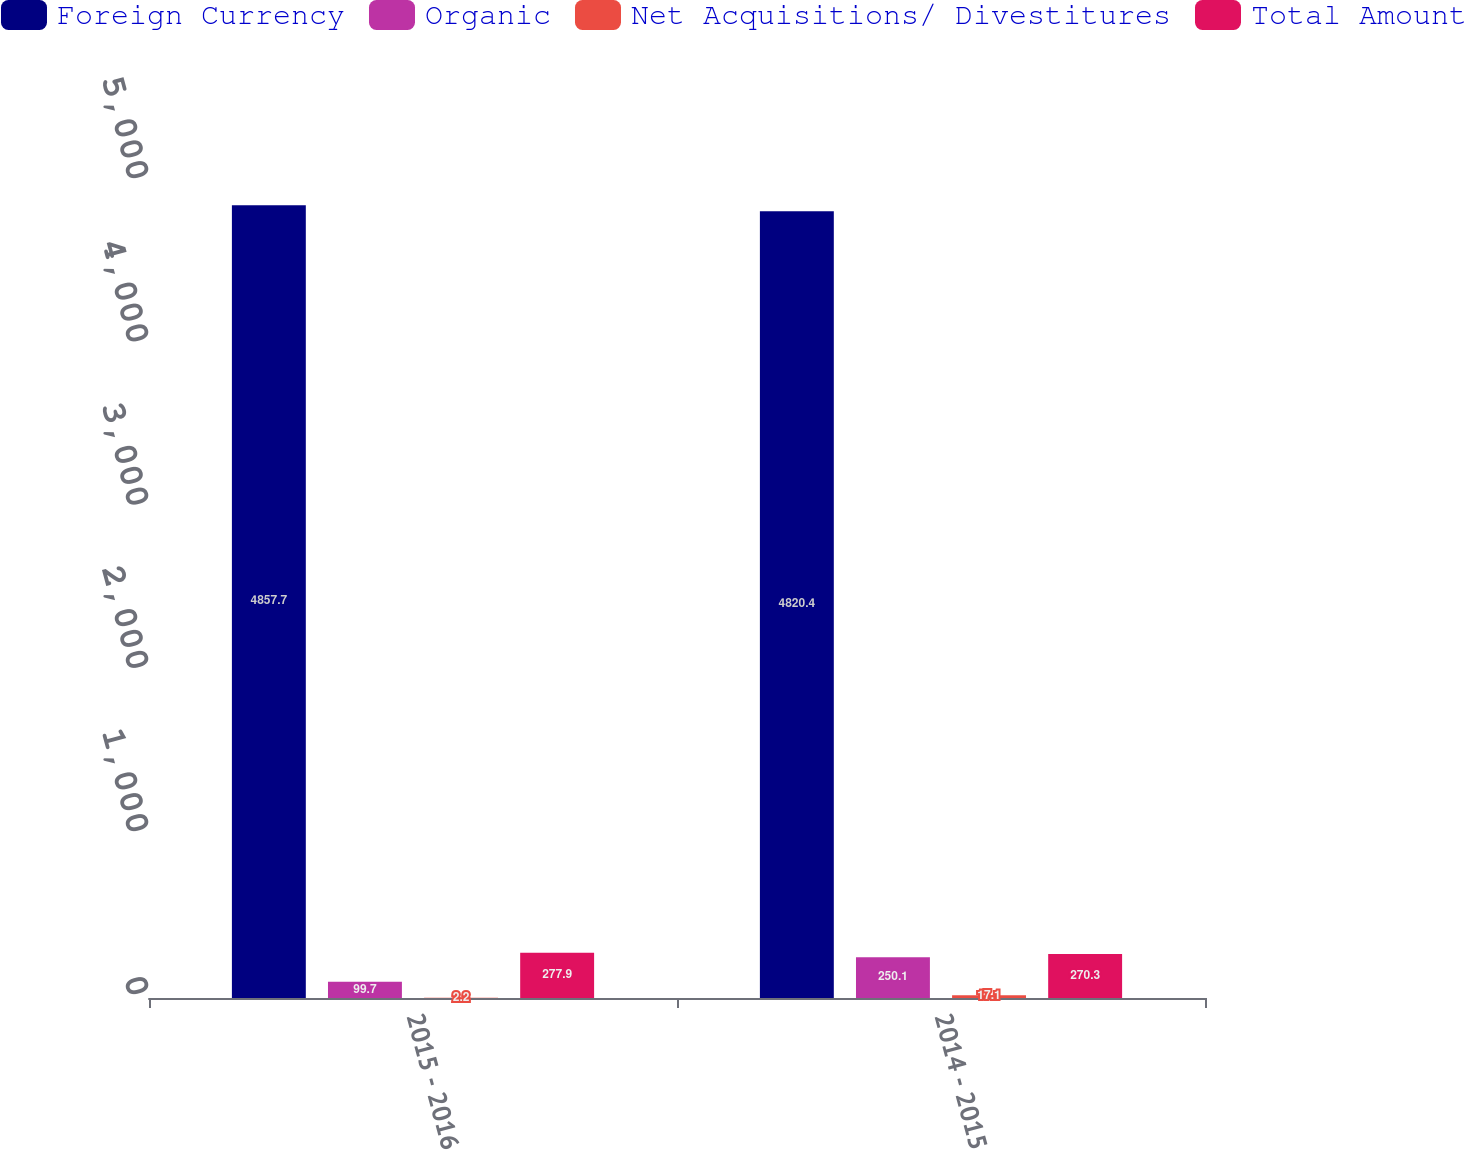Convert chart to OTSL. <chart><loc_0><loc_0><loc_500><loc_500><stacked_bar_chart><ecel><fcel>2015 - 2016<fcel>2014 - 2015<nl><fcel>Foreign Currency<fcel>4857.7<fcel>4820.4<nl><fcel>Organic<fcel>99.7<fcel>250.1<nl><fcel>Net Acquisitions/ Divestitures<fcel>2.2<fcel>17.1<nl><fcel>Total Amount<fcel>277.9<fcel>270.3<nl></chart> 